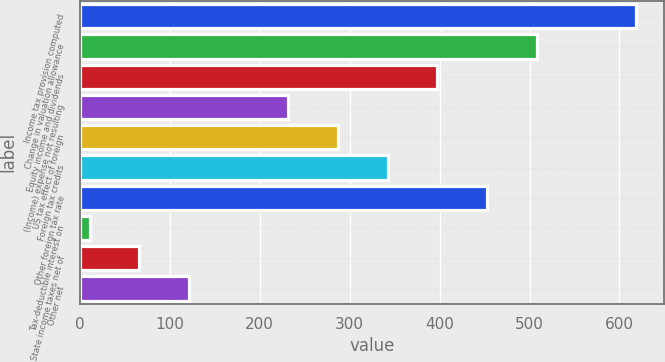Convert chart. <chart><loc_0><loc_0><loc_500><loc_500><bar_chart><fcel>Income tax provision computed<fcel>Change in valuation allowance<fcel>Equity income and dividends<fcel>(Income) expense not resulting<fcel>US tax effect of foreign<fcel>Foreign tax credits<fcel>Other foreign tax rate<fcel>Tax-deductible interest on<fcel>State income taxes net of<fcel>Other net<nl><fcel>618.2<fcel>507.8<fcel>397.4<fcel>231.8<fcel>287<fcel>342.2<fcel>452.6<fcel>11<fcel>66.2<fcel>121.4<nl></chart> 